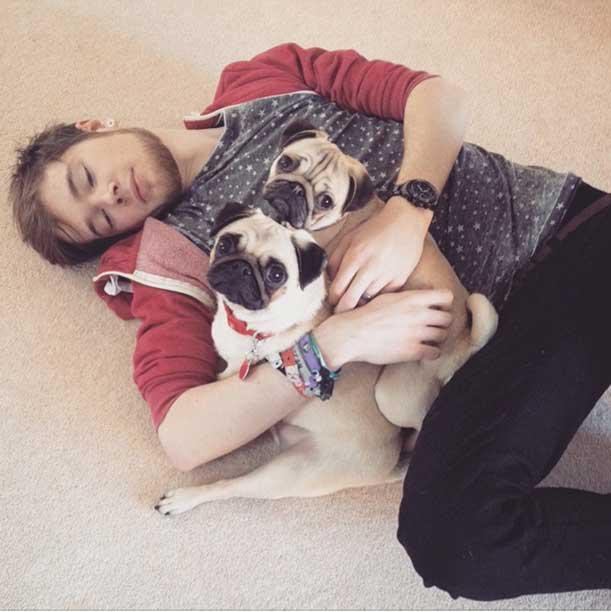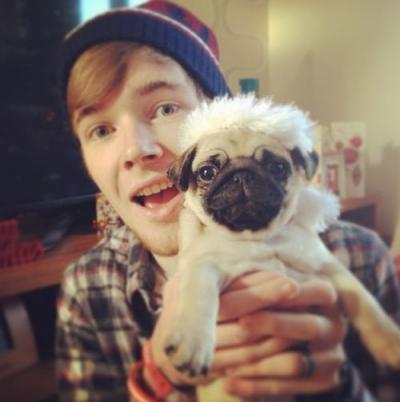The first image is the image on the left, the second image is the image on the right. Given the left and right images, does the statement "A dog is wearing something on its head." hold true? Answer yes or no. Yes. The first image is the image on the left, the second image is the image on the right. Analyze the images presented: Is the assertion "At least one image shows a human behind the dog hugging it." valid? Answer yes or no. Yes. 